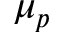<formula> <loc_0><loc_0><loc_500><loc_500>\mu _ { p }</formula> 